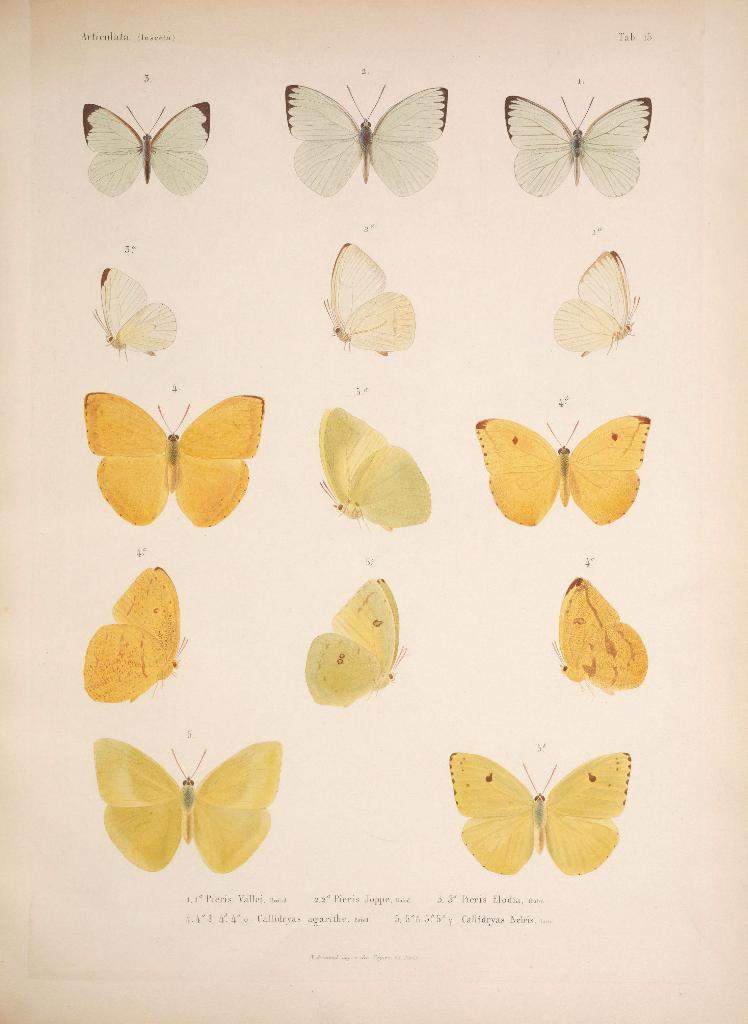What is the main subject of the image? The main subject of the image is photos of different types of butterflies. Are there any other items or objects in the image besides the butterfly photos? Yes, there are words on a paper in the image. What role does the father play in the butterfly society depicted in the image? There is no father or butterfly society present in the image; it only features photos of butterflies and words on a paper. 